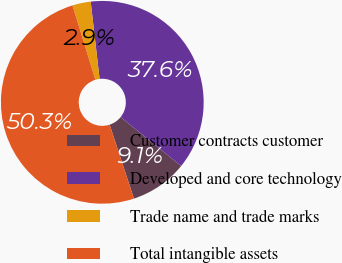<chart> <loc_0><loc_0><loc_500><loc_500><pie_chart><fcel>Customer contracts customer<fcel>Developed and core technology<fcel>Trade name and trade marks<fcel>Total intangible assets<nl><fcel>9.13%<fcel>37.64%<fcel>2.92%<fcel>50.3%<nl></chart> 